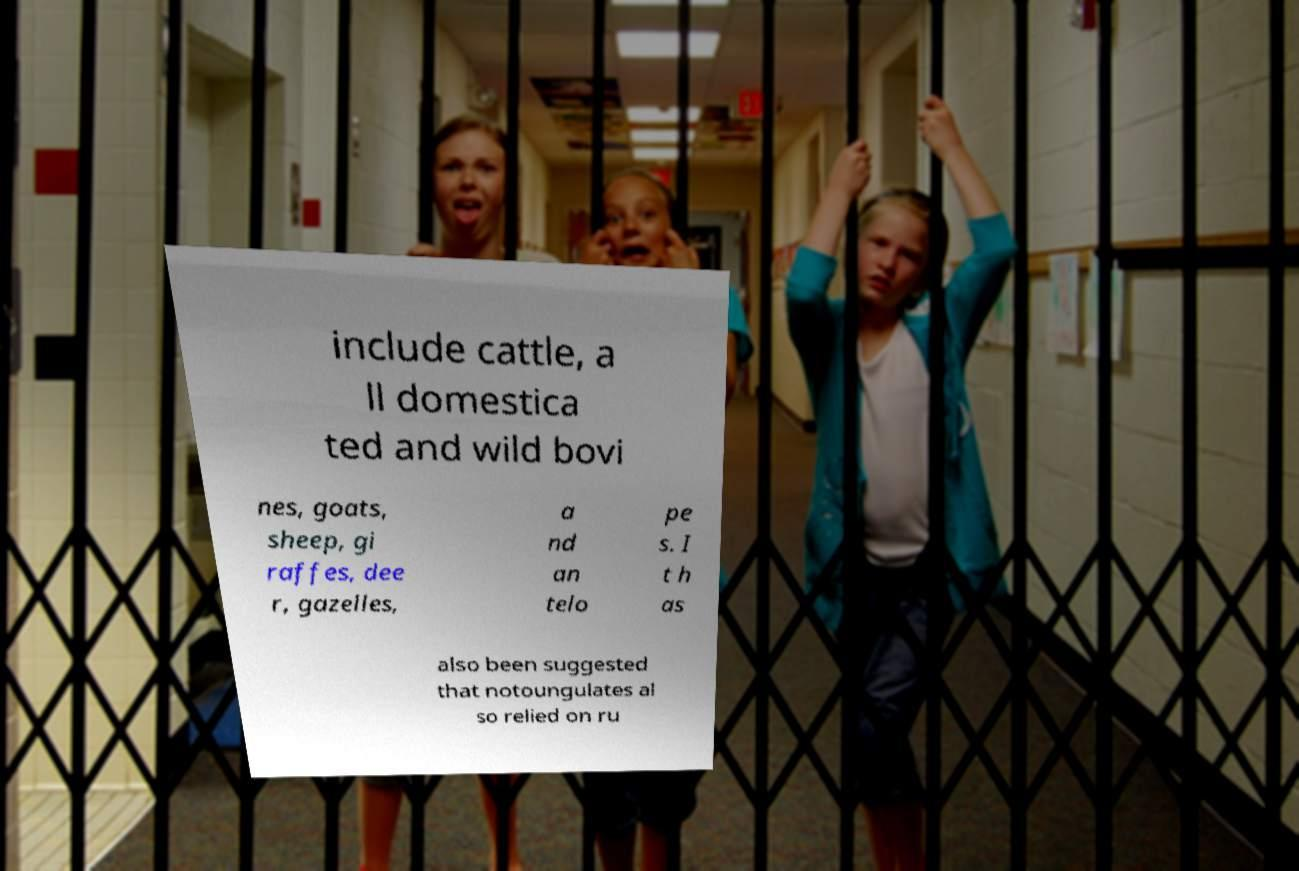There's text embedded in this image that I need extracted. Can you transcribe it verbatim? include cattle, a ll domestica ted and wild bovi nes, goats, sheep, gi raffes, dee r, gazelles, a nd an telo pe s. I t h as also been suggested that notoungulates al so relied on ru 